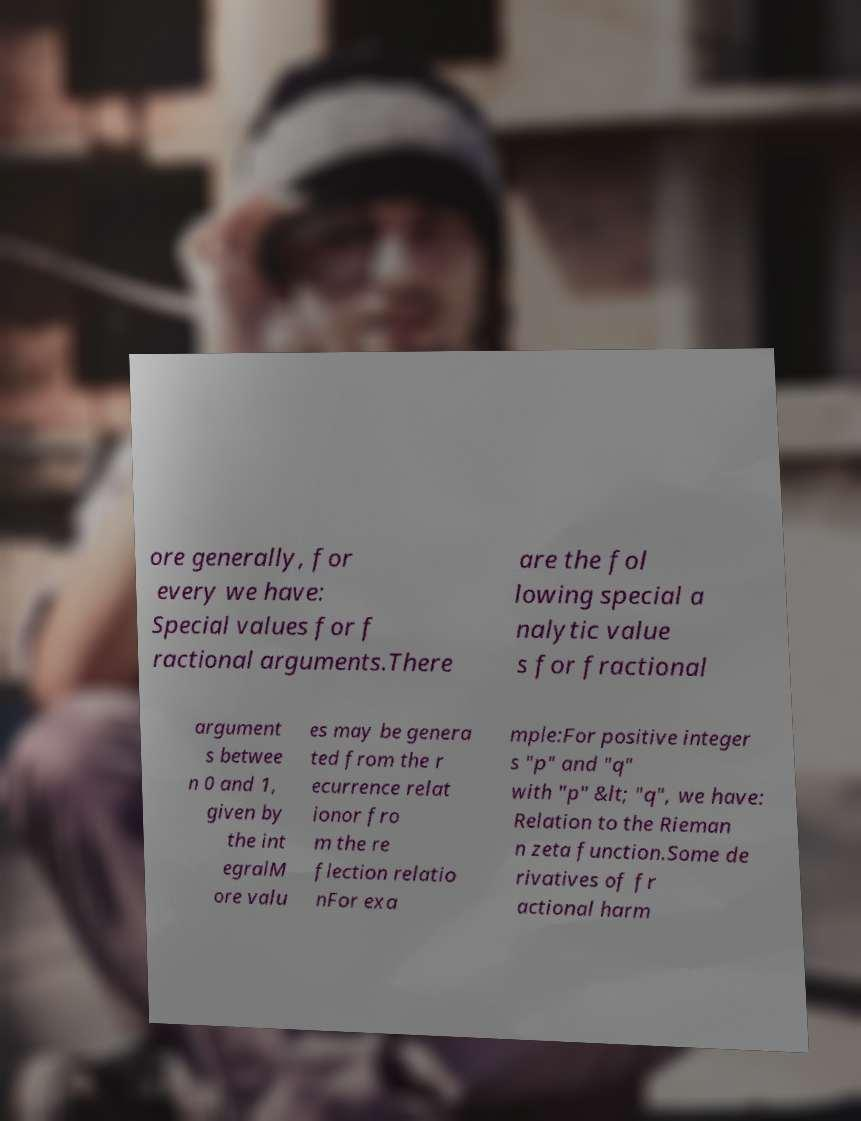Could you assist in decoding the text presented in this image and type it out clearly? ore generally, for every we have: Special values for f ractional arguments.There are the fol lowing special a nalytic value s for fractional argument s betwee n 0 and 1, given by the int egralM ore valu es may be genera ted from the r ecurrence relat ionor fro m the re flection relatio nFor exa mple:For positive integer s "p" and "q" with "p" &lt; "q", we have: Relation to the Rieman n zeta function.Some de rivatives of fr actional harm 